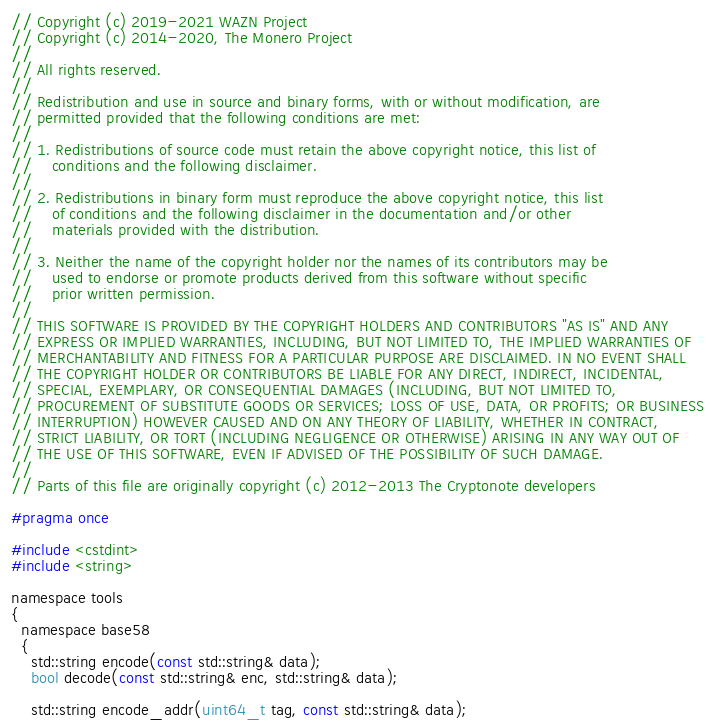Convert code to text. <code><loc_0><loc_0><loc_500><loc_500><_C_>// Copyright (c) 2019-2021 WAZN Project
// Copyright (c) 2014-2020, The Monero Project
//
// All rights reserved.
//
// Redistribution and use in source and binary forms, with or without modification, are
// permitted provided that the following conditions are met:
//
// 1. Redistributions of source code must retain the above copyright notice, this list of
//    conditions and the following disclaimer.
//
// 2. Redistributions in binary form must reproduce the above copyright notice, this list
//    of conditions and the following disclaimer in the documentation and/or other
//    materials provided with the distribution.
//
// 3. Neither the name of the copyright holder nor the names of its contributors may be
//    used to endorse or promote products derived from this software without specific
//    prior written permission.
//
// THIS SOFTWARE IS PROVIDED BY THE COPYRIGHT HOLDERS AND CONTRIBUTORS "AS IS" AND ANY
// EXPRESS OR IMPLIED WARRANTIES, INCLUDING, BUT NOT LIMITED TO, THE IMPLIED WARRANTIES OF
// MERCHANTABILITY AND FITNESS FOR A PARTICULAR PURPOSE ARE DISCLAIMED. IN NO EVENT SHALL
// THE COPYRIGHT HOLDER OR CONTRIBUTORS BE LIABLE FOR ANY DIRECT, INDIRECT, INCIDENTAL,
// SPECIAL, EXEMPLARY, OR CONSEQUENTIAL DAMAGES (INCLUDING, BUT NOT LIMITED TO,
// PROCUREMENT OF SUBSTITUTE GOODS OR SERVICES; LOSS OF USE, DATA, OR PROFITS; OR BUSINESS
// INTERRUPTION) HOWEVER CAUSED AND ON ANY THEORY OF LIABILITY, WHETHER IN CONTRACT,
// STRICT LIABILITY, OR TORT (INCLUDING NEGLIGENCE OR OTHERWISE) ARISING IN ANY WAY OUT OF
// THE USE OF THIS SOFTWARE, EVEN IF ADVISED OF THE POSSIBILITY OF SUCH DAMAGE.
//
// Parts of this file are originally copyright (c) 2012-2013 The Cryptonote developers

#pragma once

#include <cstdint>
#include <string>

namespace tools
{
  namespace base58
  {
    std::string encode(const std::string& data);
    bool decode(const std::string& enc, std::string& data);

    std::string encode_addr(uint64_t tag, const std::string& data);</code> 